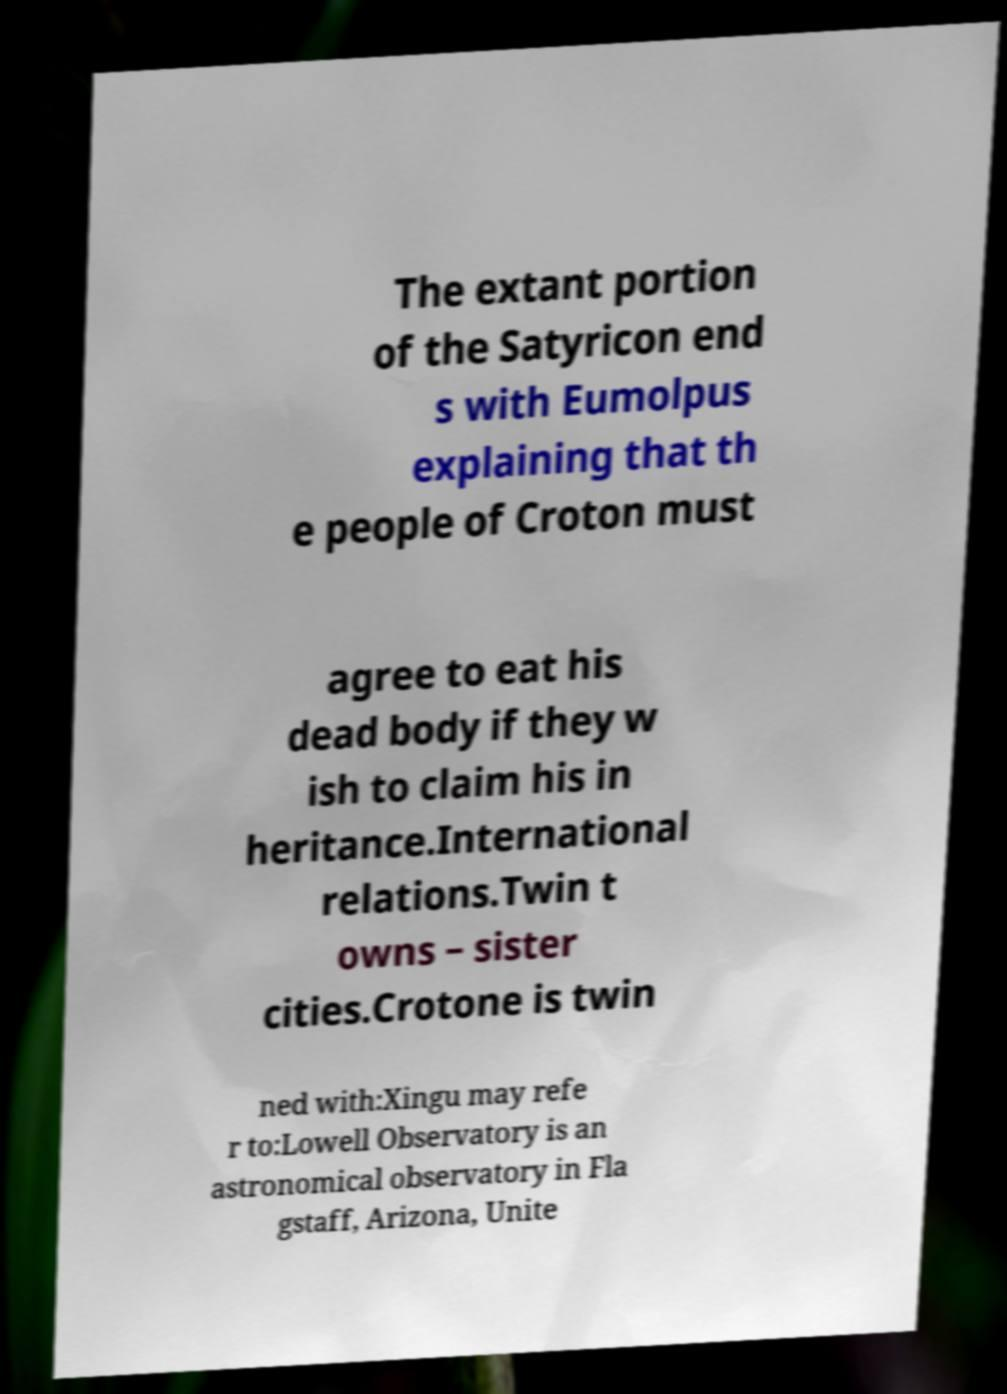Could you extract and type out the text from this image? The extant portion of the Satyricon end s with Eumolpus explaining that th e people of Croton must agree to eat his dead body if they w ish to claim his in heritance.International relations.Twin t owns – sister cities.Crotone is twin ned with:Xingu may refe r to:Lowell Observatory is an astronomical observatory in Fla gstaff, Arizona, Unite 